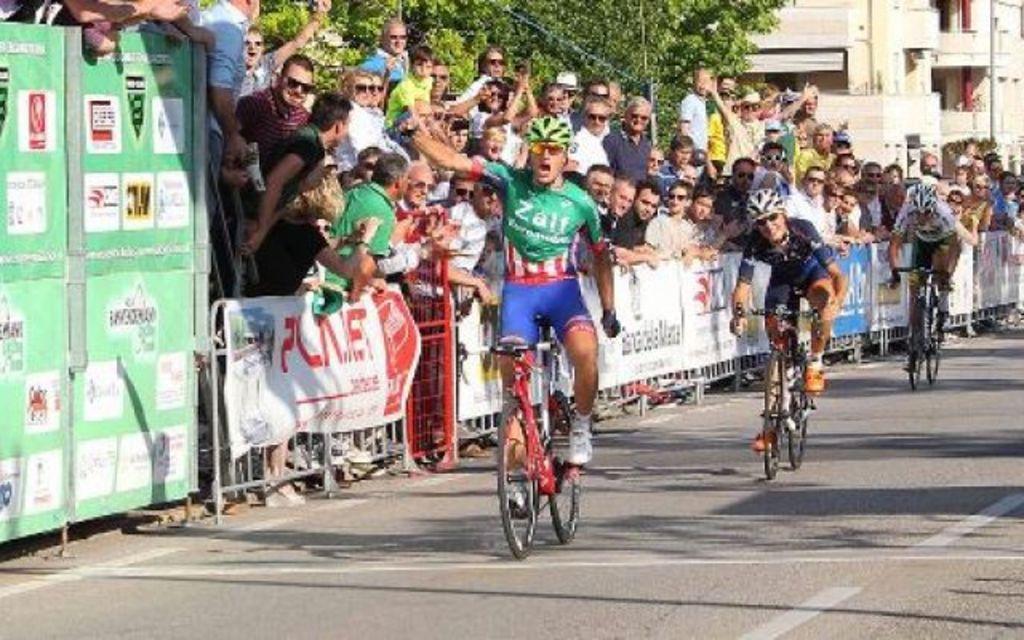In one or two sentences, can you explain what this image depicts? As we can see in the image there are banners, fence, three people wearing helmets and riding bicycles. There are group of people watching them. In the background there are buildings and trees. 